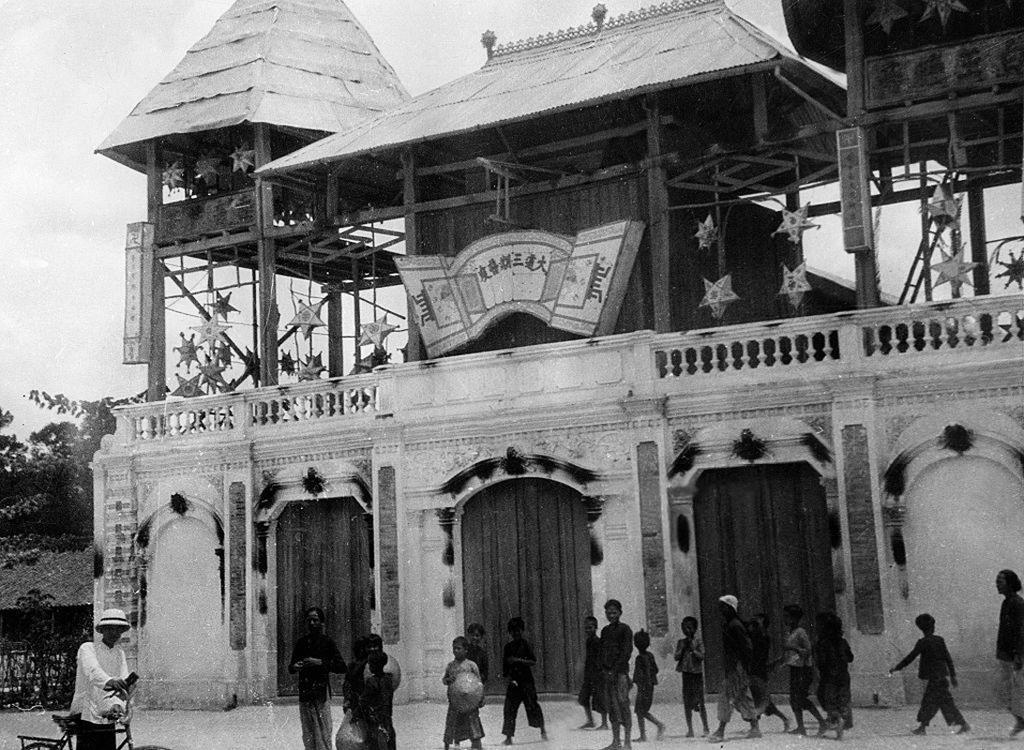Could you give a brief overview of what you see in this image? In this picture there are people and we can see building, decorative items and trees. In the background of the image we can see the sky. 